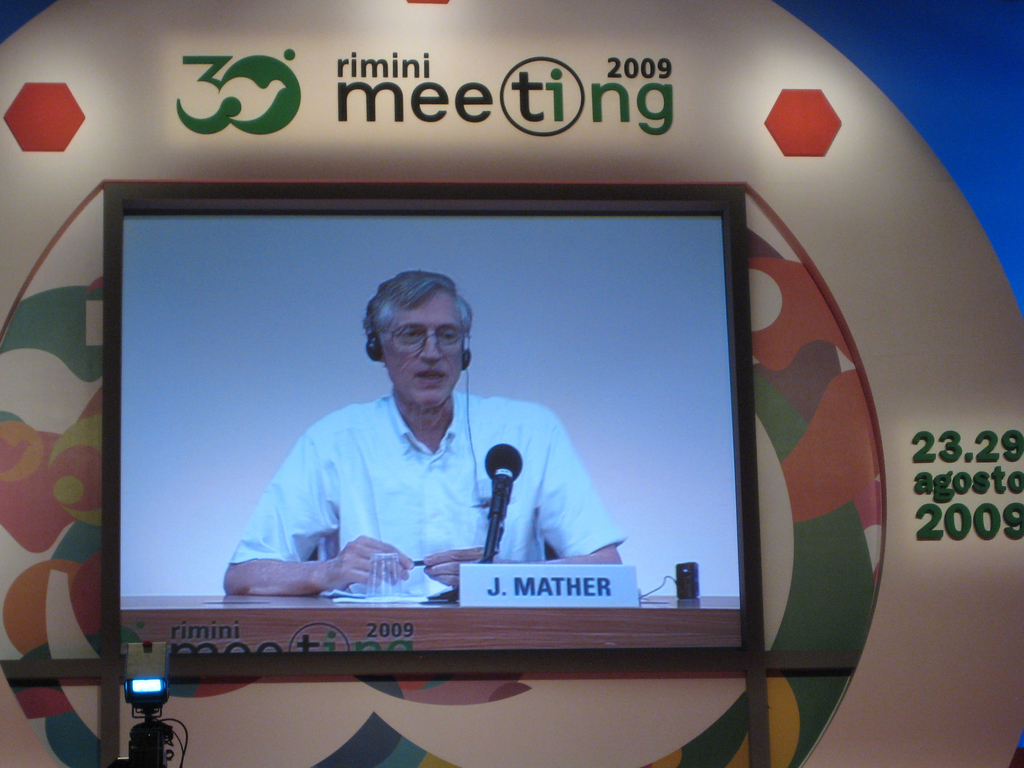Can you describe the significance of the setting shown in the 2009 picture? The setting of the 2009 Rimini Meeting, marked by its vibrant backdrop and large audience, underscores the event's importance as a hub for intellectual discourse. It provides a platform for influential thinkers to share perspectives and inspire an audience that values deep and thoughtful discussion on pressing global matters. What impact do such meetings have on attendees and speakers? Meetings like the Rimini Meeting serve as catalysts for intellectual growth and networking, enabling attendees and speakers to exchange ideas, form collaborations, and expand their understanding of various global issues. They often leave with renewed inspiration and practical insights that influence their personal and professional lives. 